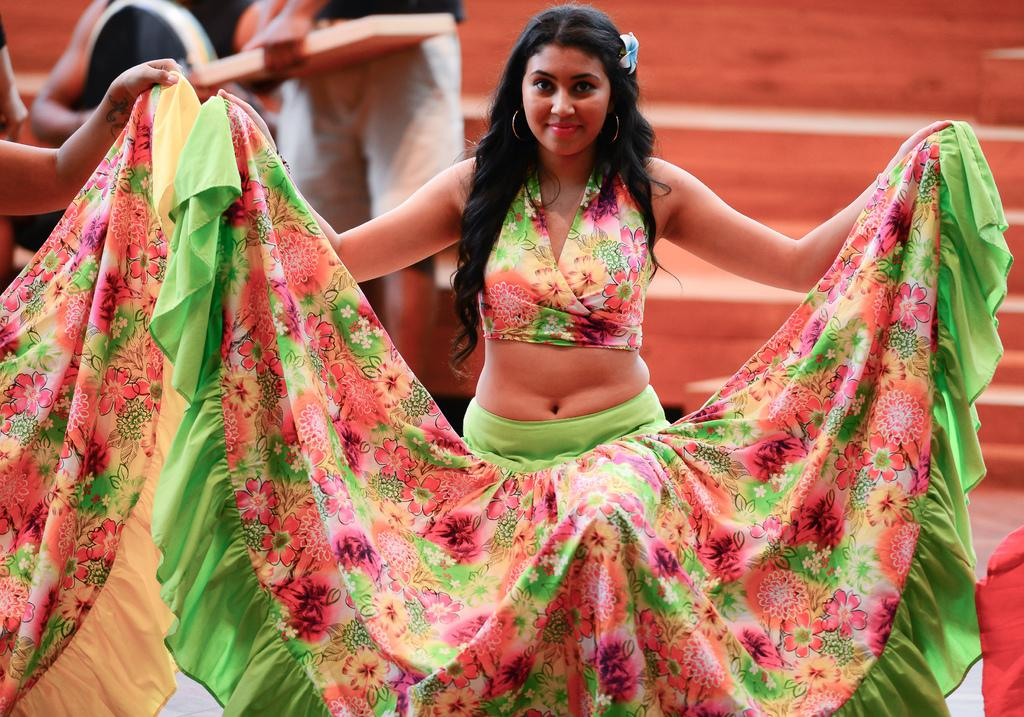What type of architectural feature can be seen in the background of the image? There are stairs in the background of the image. What else can be seen in the background of the image? There are people in the background of the image. Can you describe the woman in the image? The woman in the image is standing, has long and black hair, and is holding her skirt with her hands. What is the woman's facial expression in the image? The woman is smiling in the image. What type of print is visible on the woman's skirt in the image? There is no print visible on the woman's skirt in the image; it is not mentioned in the provided facts. What kind of pie is the woman holding in the image? There is no pie present in the image; the woman is holding her skirt with her hands. 